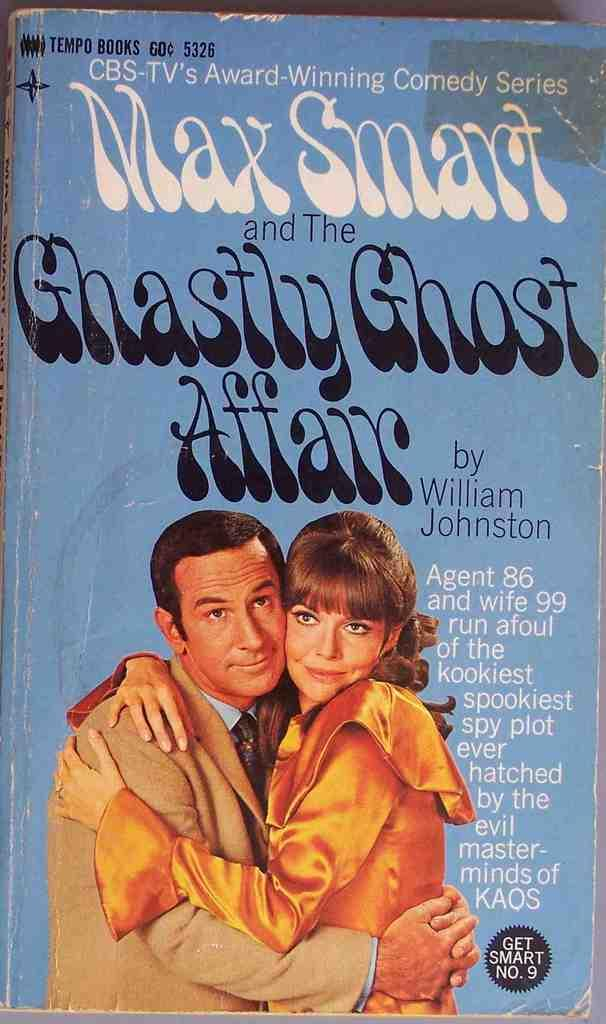<image>
Share a concise interpretation of the image provided. the cover of a book called 'max smart and the ghastly ghost affair' 